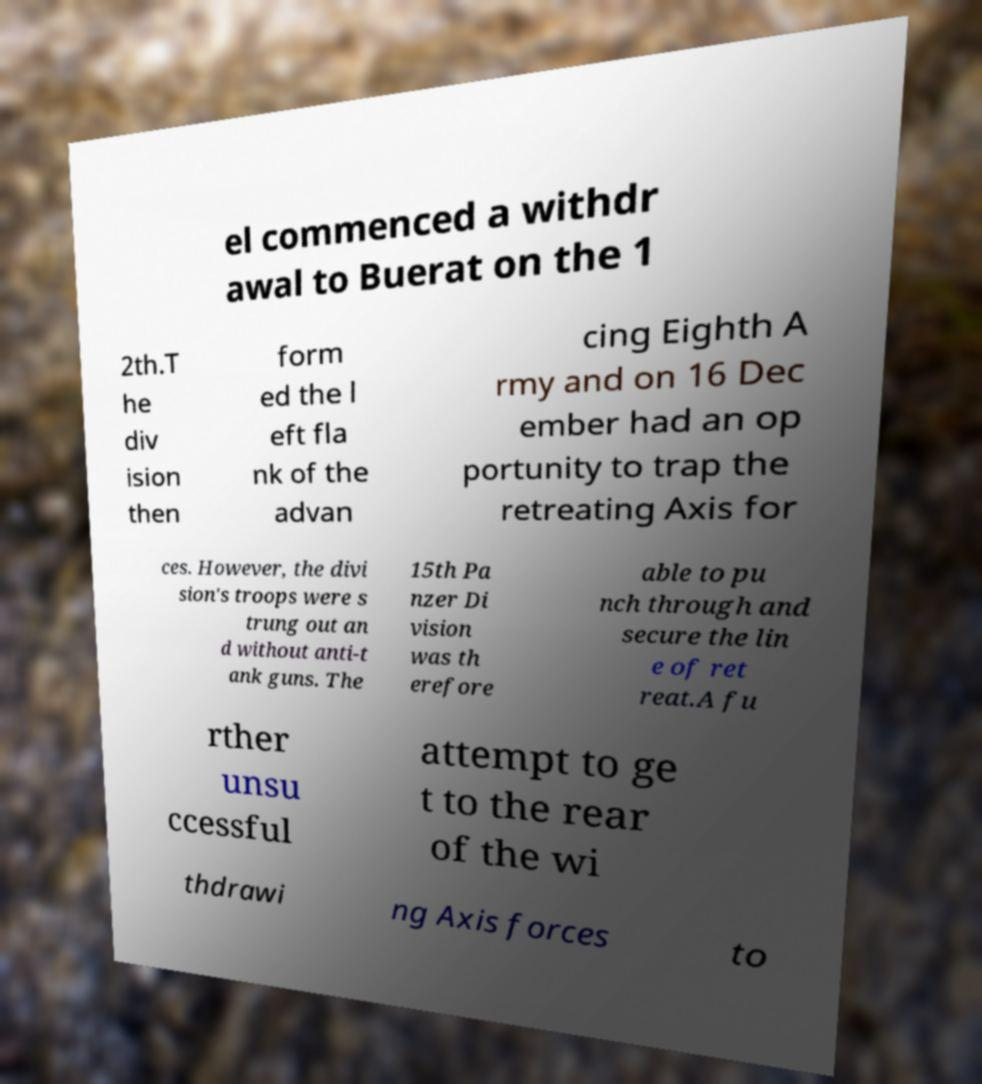Can you accurately transcribe the text from the provided image for me? el commenced a withdr awal to Buerat on the 1 2th.T he div ision then form ed the l eft fla nk of the advan cing Eighth A rmy and on 16 Dec ember had an op portunity to trap the retreating Axis for ces. However, the divi sion's troops were s trung out an d without anti-t ank guns. The 15th Pa nzer Di vision was th erefore able to pu nch through and secure the lin e of ret reat.A fu rther unsu ccessful attempt to ge t to the rear of the wi thdrawi ng Axis forces to 